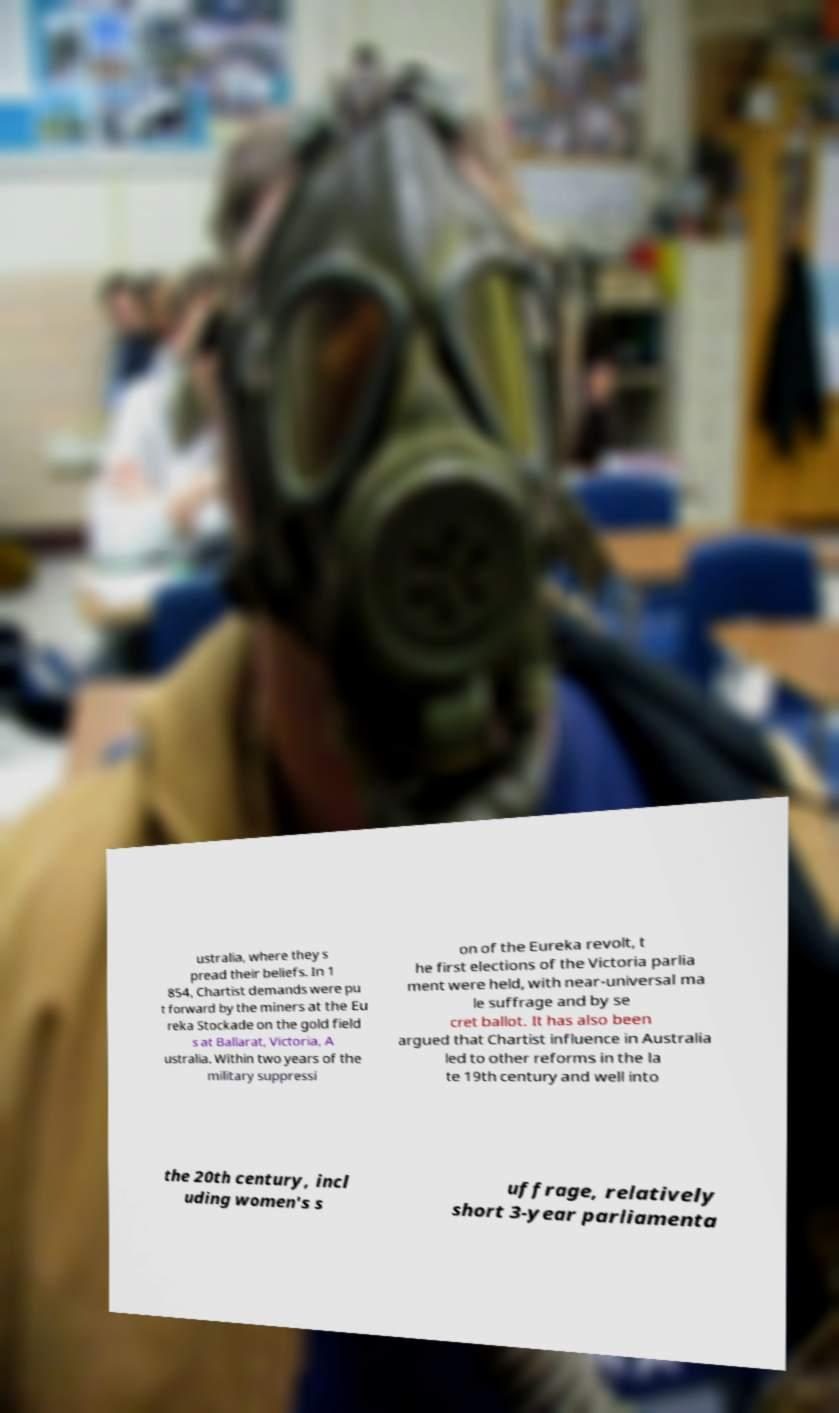Can you read and provide the text displayed in the image?This photo seems to have some interesting text. Can you extract and type it out for me? ustralia, where they s pread their beliefs. In 1 854, Chartist demands were pu t forward by the miners at the Eu reka Stockade on the gold field s at Ballarat, Victoria, A ustralia. Within two years of the military suppressi on of the Eureka revolt, t he first elections of the Victoria parlia ment were held, with near-universal ma le suffrage and by se cret ballot. It has also been argued that Chartist influence in Australia led to other reforms in the la te 19th century and well into the 20th century, incl uding women's s uffrage, relatively short 3-year parliamenta 